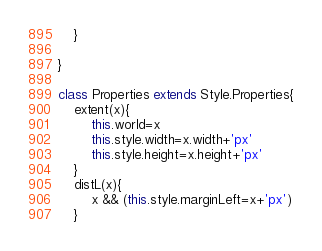Convert code to text. <code><loc_0><loc_0><loc_500><loc_500><_JavaScript_>	}

}

class Properties extends Style.Properties{
	extent(x){
		this.world=x
		this.style.width=x.width+'px'
		this.style.height=x.height+'px'
	}
	distL(x){
		x && (this.style.marginLeft=x+'px')
	}</code> 